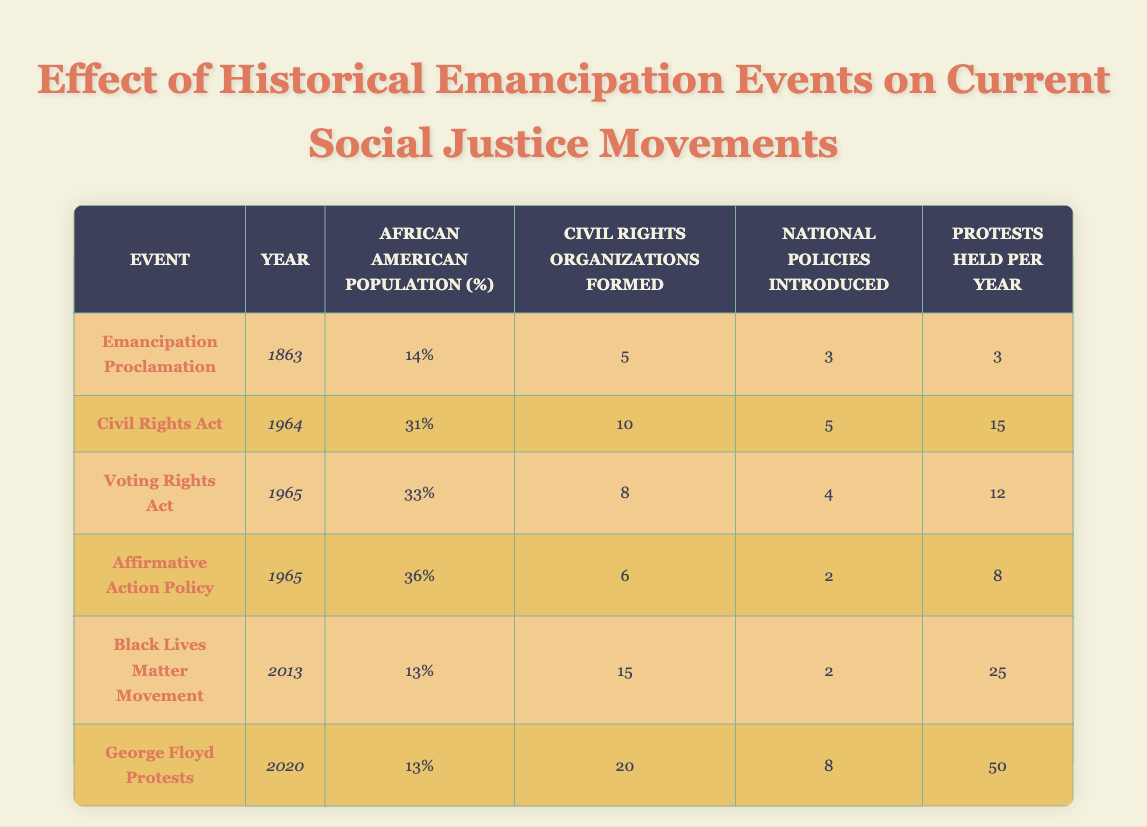What percentage of the African American population was recorded in 1964? The table shows the data for 1964 under the "African American Population (%)" column, which states it was 31%.
Answer: 31% How many civil rights organizations were formed by the time of the Voting Rights Act? Referring to the 1965 row in the table, it indicates that there were 8 civil rights organizations formed.
Answer: 8 What is the total number of protests held per year from the years listed in the table? To find the total, we add the protests held per year for all the events: 3 (1863) + 15 (1964) + 12 (1965) + 8 (1965) + 25 (2013) + 50 (2020) = 113.
Answer: 113 Did the number of civil rights organizations formed increase from the Emancipation Proclamation to the George Floyd protests? The Emancipation Proclamation (5 organizations) and the George Floyd protests (20 organizations) show an increase in civil rights organizations formed over that period.
Answer: Yes What was the average number of protests held per year for the events that occurred in 1965? In 1965, there were two events: the Voting Rights Act (12 protests) and Affirmative Action Policy (8 protests). The average is calculated as (12 + 8) / 2 = 10.
Answer: 10 How many national policies were introduced in total from the events listed? Adding the national policies from all events: 3 (1863) + 5 (1964) + 4 (1965) + 2 (1965) + 2 (2013) + 8 (2020) = 24.
Answer: 24 Was the African American population percentage higher during the Civil Rights Act or the Voting Rights Act? The Civil Rights Act (31%) had a lower percentage than the Voting Rights Act (33%), indicating a rise in African American population percentage by the time of the Voting Rights Act.
Answer: Voting Rights Act How much did the number of protests held per year increase from the Civil Rights Act in 1964 to the George Floyd protests in 2020? To find the increase: 50 (2020) - 15 (1964) = 35. This signifies a rise of 35 protests held per year over this period.
Answer: 35 